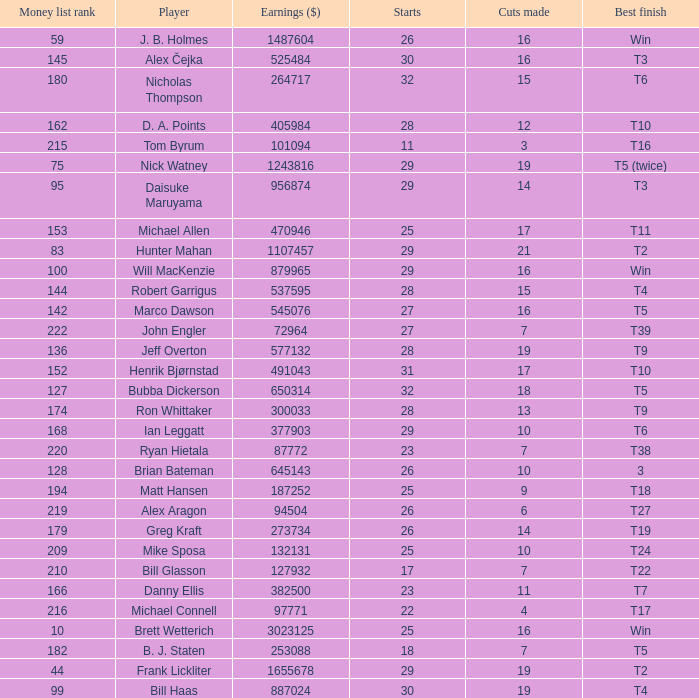What is the minimum number of cuts made for Hunter Mahan? 21.0. 